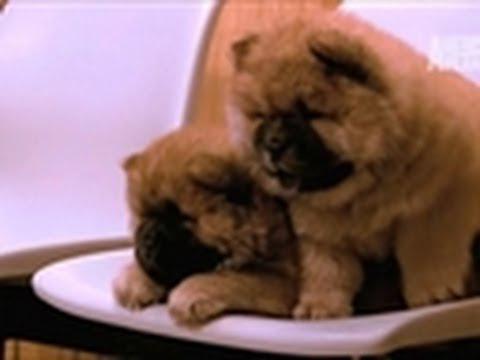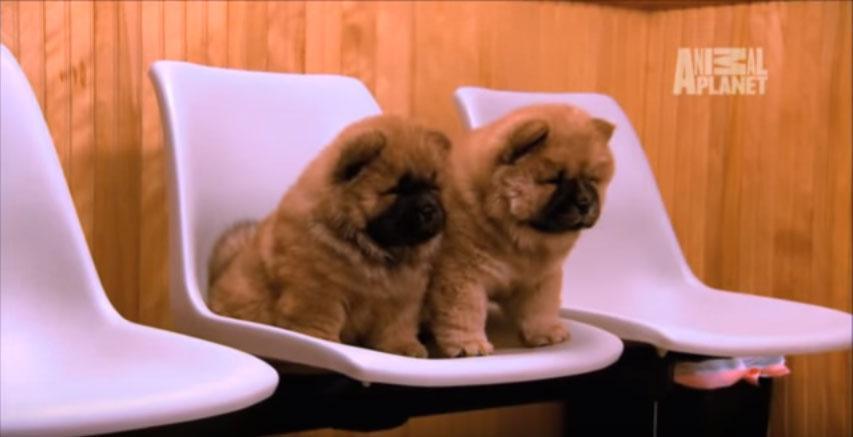The first image is the image on the left, the second image is the image on the right. Examine the images to the left and right. Is the description "The image on the right has one dog with a toy in its mouth." accurate? Answer yes or no. No. The first image is the image on the left, the second image is the image on the right. For the images displayed, is the sentence "One of the dogs has something in its mouth." factually correct? Answer yes or no. No. 